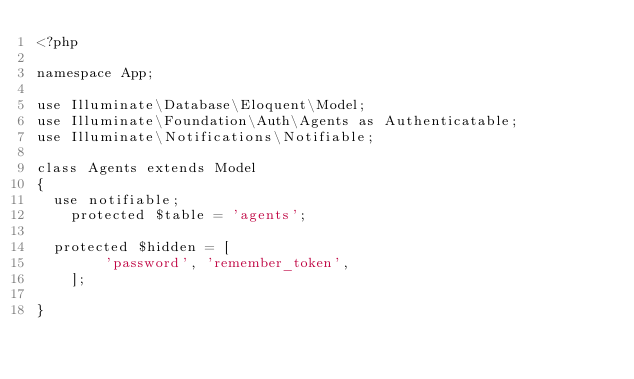<code> <loc_0><loc_0><loc_500><loc_500><_PHP_><?php

namespace App;

use Illuminate\Database\Eloquent\Model;
use Illuminate\Foundation\Auth\Agents as Authenticatable;
use Illuminate\Notifications\Notifiable;

class Agents extends Model
{
	use notifiable;
    protected $table = 'agents';
	
	protected $hidden = [
        'password', 'remember_token',
    ];
   
}
</code> 